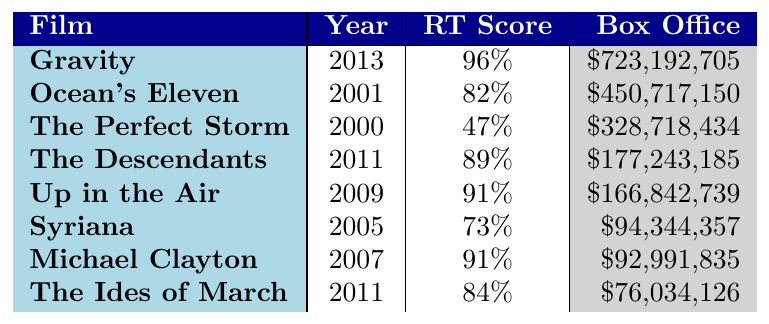What is the title of George Clooney's highest-grossing drama film? The highest box office figure in the table is $723,192,705 for the film "Gravity."
Answer: Gravity What year was "The Perfect Storm" released? By referring to the table, we see that "The Perfect Storm" was released in the year 2000.
Answer: 2000 What is the Rotten Tomatoes score for "Up in the Air"? The Rotten Tomatoes score for "Up in the Air," as shown in the table, is 91%.
Answer: 91% What is the difference in box office earnings between "Ocean's Eleven" and "Syriana"? The box office for "Ocean's Eleven" is $450,717,150 and for "Syriana" is $94,344,357. The difference is $450,717,150 - $94,344,357 = $356,372,793.
Answer: $356,372,793 Is "The Ides of March" rated higher than "Michael Clayton" on Rotten Tomatoes? "The Ides of March" has a Rotten Tomatoes score of 84%, whereas "Michael Clayton" has a score of 91%. Therefore, "The Ides of March" is not rated higher.
Answer: No What is the average Rotten Tomatoes score of the films listed? The scores are 96, 82, 47, 89, 91, 73, 91, and 84. Summing these gives 96 + 82 + 47 + 89 + 91 + 73 + 91 + 84 = 563. Dividing by the number of films (8) gives 563 / 8 = 70.375.
Answer: 70.375 Which film has the lowest box office revenue and what is that amount? By scanning the box office values in the table, the lowest is for "The Ides of March" at $76,034,126.
Answer: $76,034,126 How many films listed have a Rotten Tomatoes score of 90% or higher? The films with scores of 90% or higher are "Gravity" (96%), "Up in the Air" (91%), and "Michael Clayton" (91%). Thus, there are three such films.
Answer: 3 What would be the total box office revenue of all the films listed? Summing the box office revenues: 723,192,705 + 450,717,150 + 328,718,434 + 177,243,185 + 166,842,739 + 94,344,357 + 92,991,835 + 76,034,126 = 2,109,484,520.
Answer: $2,109,484,520 Which film from 2011 has the highest Rotten Tomatoes score? The films from 2011 are "The Descendants" with 89% and "The Ides of March" with 84%. "The Descendants" has the higher score.
Answer: The Descendants What percentage of the films listed have a Rotten Tomatoes score below 80%? The only film with a score below 80% is "The Perfect Storm" at 47%. There are a total of 8 films, thus 1 out of 8 gives a percentage of 12.5%.
Answer: 12.5% 